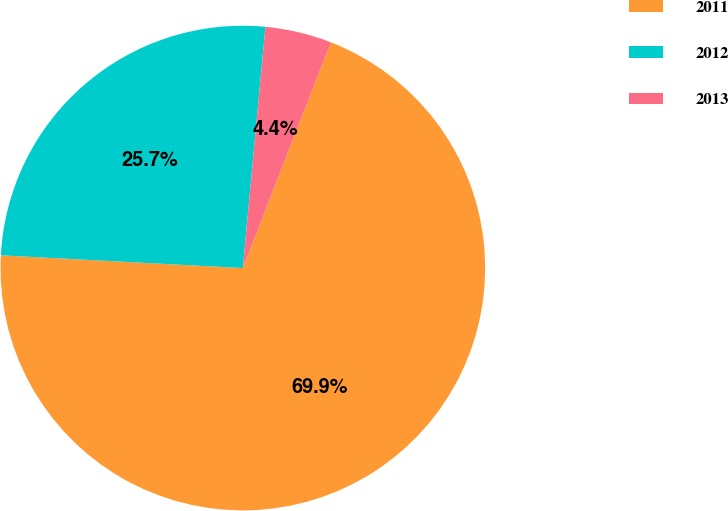Convert chart to OTSL. <chart><loc_0><loc_0><loc_500><loc_500><pie_chart><fcel>2011<fcel>2012<fcel>2013<nl><fcel>69.92%<fcel>25.65%<fcel>4.43%<nl></chart> 